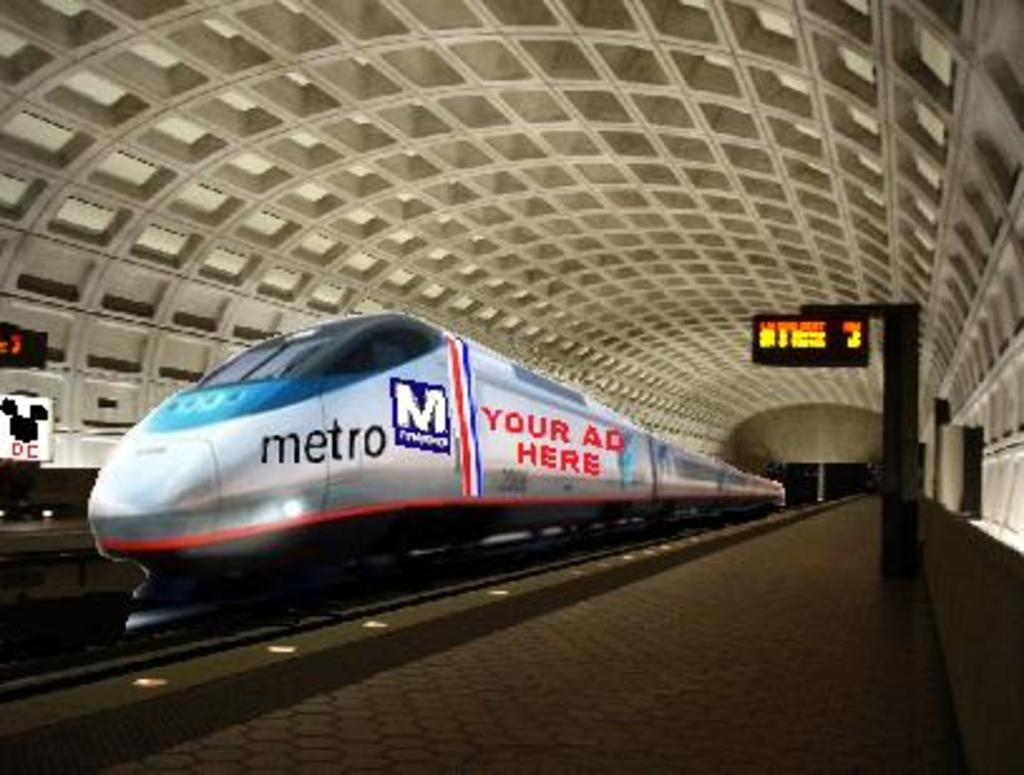What is the main subject in the foreground of the image? There is a train in the foreground of the image. What is the train's position in relation to the track? The train is on a track. What can be seen on either side of the train? There are platforms on either side of the train. What is present on the platforms? There are boards on the platforms. What part of a structure is visible at the top of the image? The image shows the inside roof of a shed at the top. What color is the airplane flying above the train in the image? There is no airplane present in the image, so we cannot determine its color. 